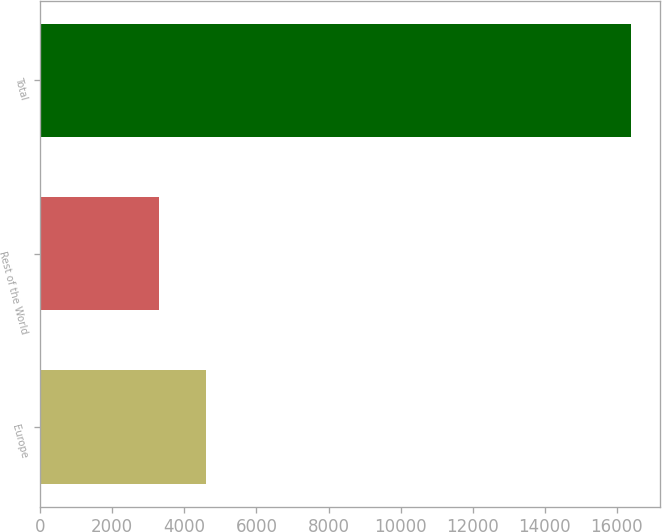Convert chart. <chart><loc_0><loc_0><loc_500><loc_500><bar_chart><fcel>Europe<fcel>Rest of the World<fcel>Total<nl><fcel>4604<fcel>3295<fcel>16385<nl></chart> 